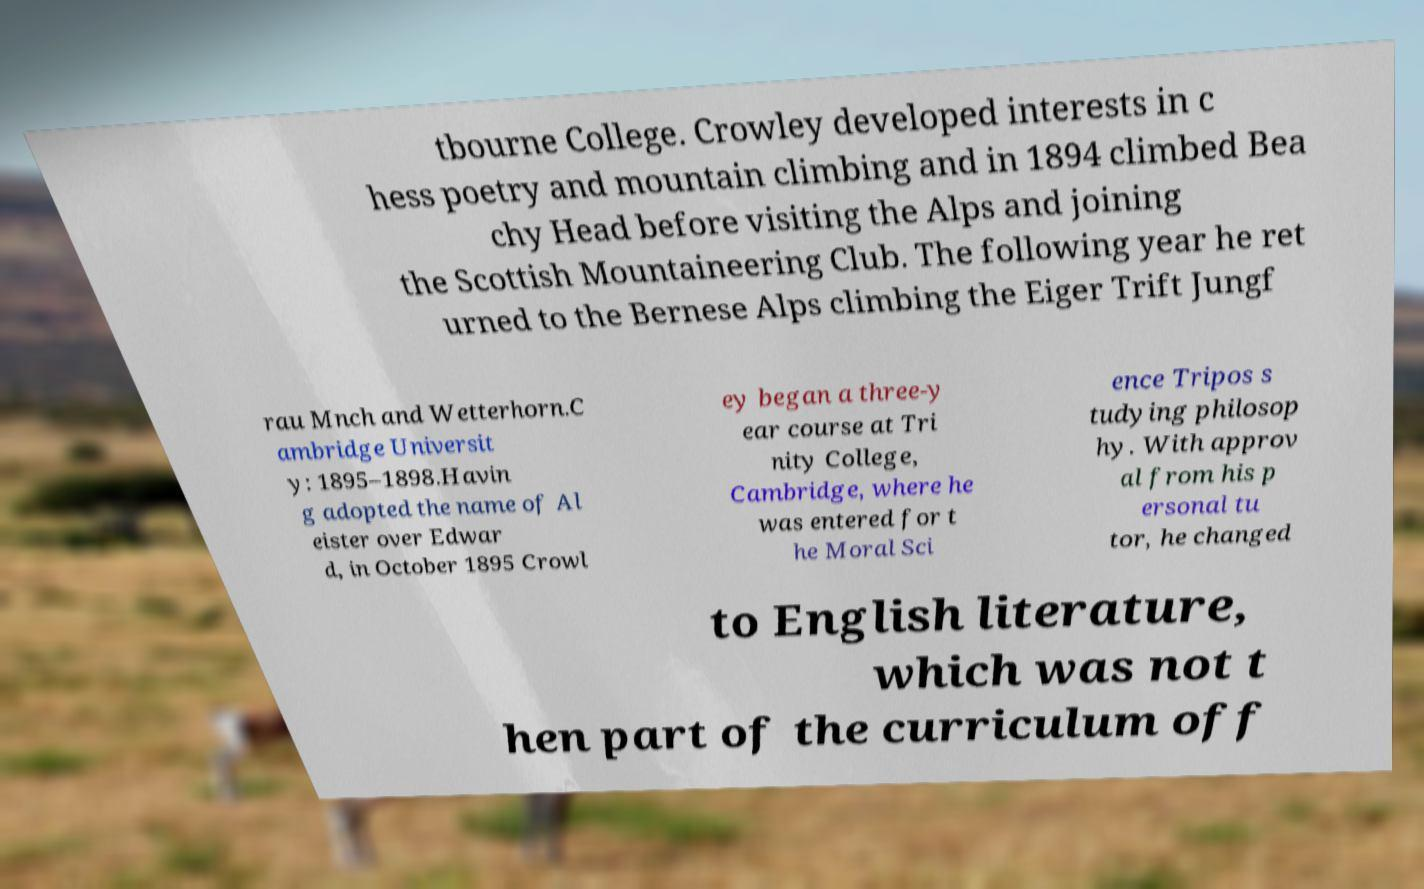Please identify and transcribe the text found in this image. tbourne College. Crowley developed interests in c hess poetry and mountain climbing and in 1894 climbed Bea chy Head before visiting the Alps and joining the Scottish Mountaineering Club. The following year he ret urned to the Bernese Alps climbing the Eiger Trift Jungf rau Mnch and Wetterhorn.C ambridge Universit y: 1895–1898.Havin g adopted the name of Al eister over Edwar d, in October 1895 Crowl ey began a three-y ear course at Tri nity College, Cambridge, where he was entered for t he Moral Sci ence Tripos s tudying philosop hy. With approv al from his p ersonal tu tor, he changed to English literature, which was not t hen part of the curriculum off 